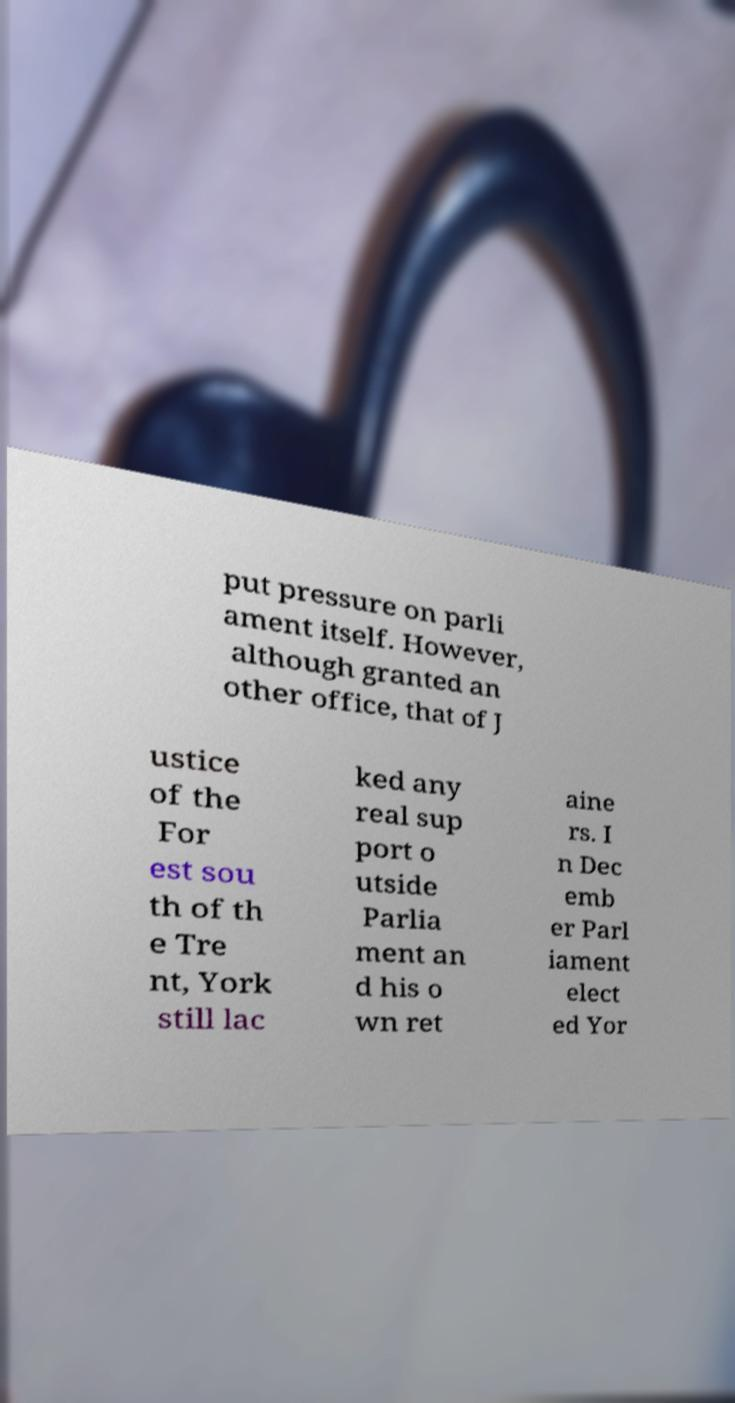There's text embedded in this image that I need extracted. Can you transcribe it verbatim? put pressure on parli ament itself. However, although granted an other office, that of J ustice of the For est sou th of th e Tre nt, York still lac ked any real sup port o utside Parlia ment an d his o wn ret aine rs. I n Dec emb er Parl iament elect ed Yor 